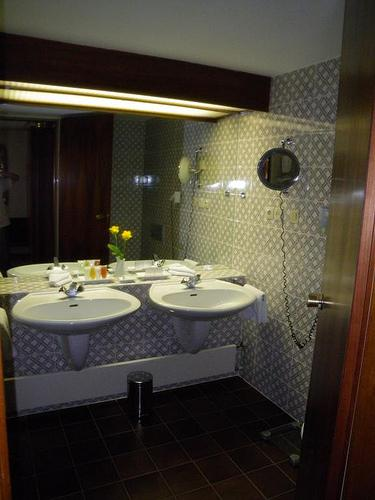Question: where in the house is this?
Choices:
A. The bathroom.
B. The kitchen.
C. The bedroom.
D. The living room.
Answer with the letter. Answer: A Question: what is under the sinks?
Choices:
A. Boxes.
B. Containers.
C. Tools.
D. Litter bin.
Answer with the letter. Answer: D Question: what is reflecting?
Choices:
A. The window.
B. The mirror.
C. The glass.
D. The piece of metal.
Answer with the letter. Answer: B Question: who is in the photo?
Choices:
A. A baby.
B. Nobody.
C. A girl.
D. A boy.
Answer with the letter. Answer: B 